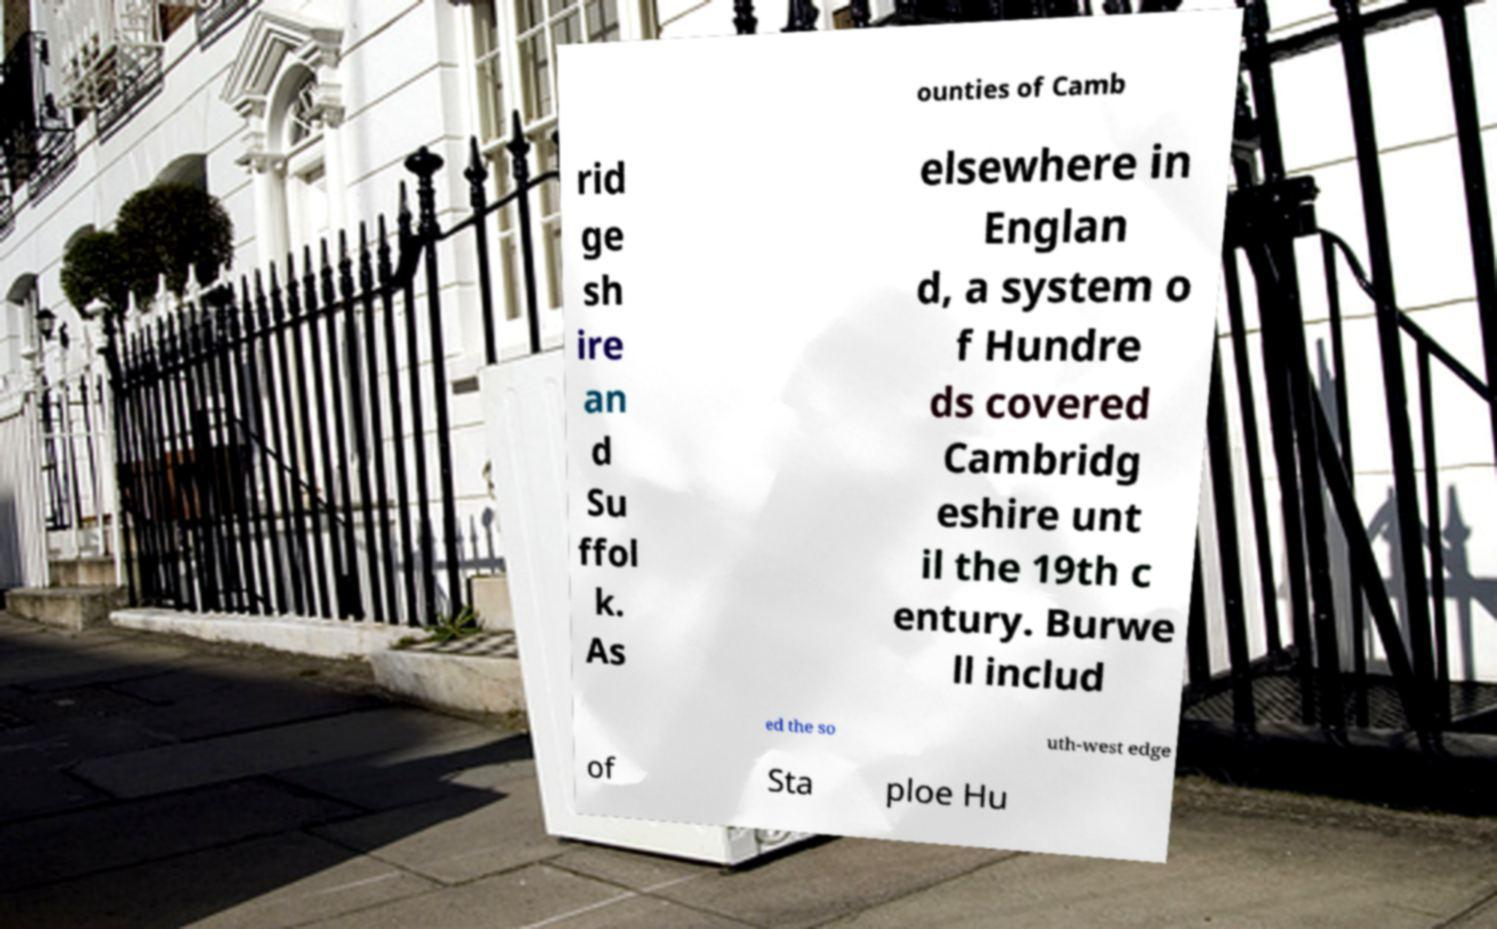There's text embedded in this image that I need extracted. Can you transcribe it verbatim? ounties of Camb rid ge sh ire an d Su ffol k. As elsewhere in Englan d, a system o f Hundre ds covered Cambridg eshire unt il the 19th c entury. Burwe ll includ ed the so uth-west edge of Sta ploe Hu 